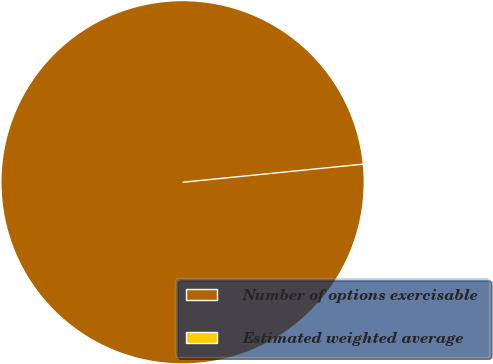Convert chart to OTSL. <chart><loc_0><loc_0><loc_500><loc_500><pie_chart><fcel>Number of options exercisable<fcel>Estimated weighted average<nl><fcel>100.0%<fcel>0.0%<nl></chart> 